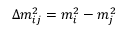Convert formula to latex. <formula><loc_0><loc_0><loc_500><loc_500>\Delta m _ { i j } ^ { 2 } = m _ { i } ^ { 2 } - m _ { j } ^ { 2 }</formula> 